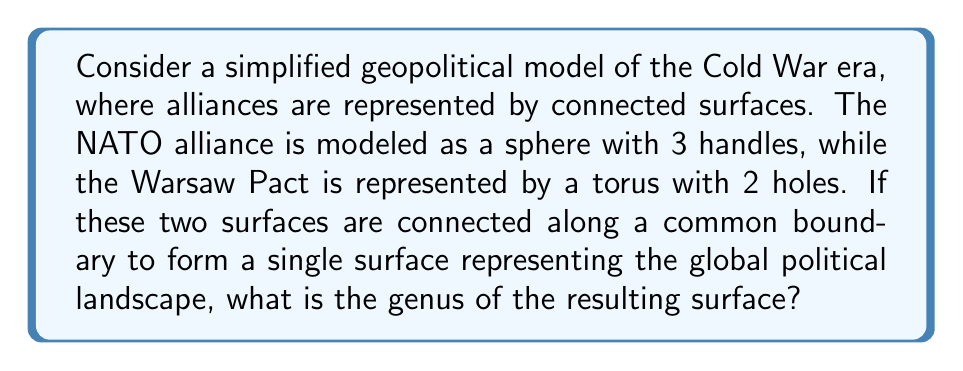Provide a solution to this math problem. To solve this problem, we need to understand the concept of genus in topology and how it applies to connected surfaces. Let's break it down step-by-step:

1. Recall that the genus of a surface is the number of handles or holes it has. Mathematically, for a connected, orientable surface:
   
   $$ g = \frac{2 - \chi}{2} $$

   where $g$ is the genus and $\chi$ is the Euler characteristic.

2. For the NATO alliance surface:
   - A sphere has genus 0
   - Adding 3 handles increases the genus by 3
   - So, the genus of the NATO surface is 3

3. For the Warsaw Pact surface:
   - A torus has genus 1
   - Adding 2 holes increases the genus by 2
   - So, the genus of the Warsaw Pact surface is 3

4. When we connect these surfaces along a common boundary, we are essentially performing a connected sum operation. The genus of a connected sum of surfaces is the sum of their individual genera minus 1:

   $$ g_{total} = g_1 + g_2 - 1 $$

5. Applying this to our problem:
   $$ g_{total} = g_{NATO} + g_{Warsaw Pact} - 1 $$
   $$ g_{total} = 3 + 3 - 1 = 5 $$

Therefore, the genus of the resulting surface representing the global political landscape is 5.

This result can be interpreted historically as representing the complex interconnections and tensions between the two major power blocs during the Cold War, with each "handle" or "hole" potentially representing areas of conflict or spheres of influence.
Answer: The genus of the resulting surface is 5. 